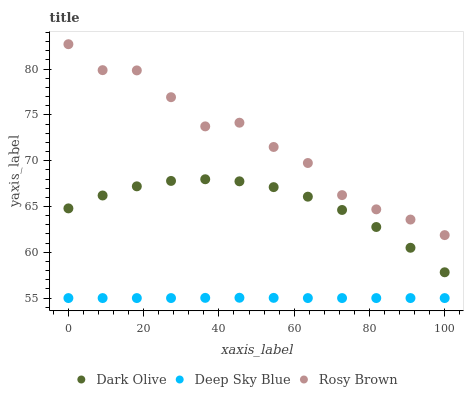Does Deep Sky Blue have the minimum area under the curve?
Answer yes or no. Yes. Does Rosy Brown have the maximum area under the curve?
Answer yes or no. Yes. Does Dark Olive have the minimum area under the curve?
Answer yes or no. No. Does Dark Olive have the maximum area under the curve?
Answer yes or no. No. Is Deep Sky Blue the smoothest?
Answer yes or no. Yes. Is Rosy Brown the roughest?
Answer yes or no. Yes. Is Dark Olive the smoothest?
Answer yes or no. No. Is Dark Olive the roughest?
Answer yes or no. No. Does Deep Sky Blue have the lowest value?
Answer yes or no. Yes. Does Dark Olive have the lowest value?
Answer yes or no. No. Does Rosy Brown have the highest value?
Answer yes or no. Yes. Does Dark Olive have the highest value?
Answer yes or no. No. Is Dark Olive less than Rosy Brown?
Answer yes or no. Yes. Is Rosy Brown greater than Deep Sky Blue?
Answer yes or no. Yes. Does Dark Olive intersect Rosy Brown?
Answer yes or no. No. 